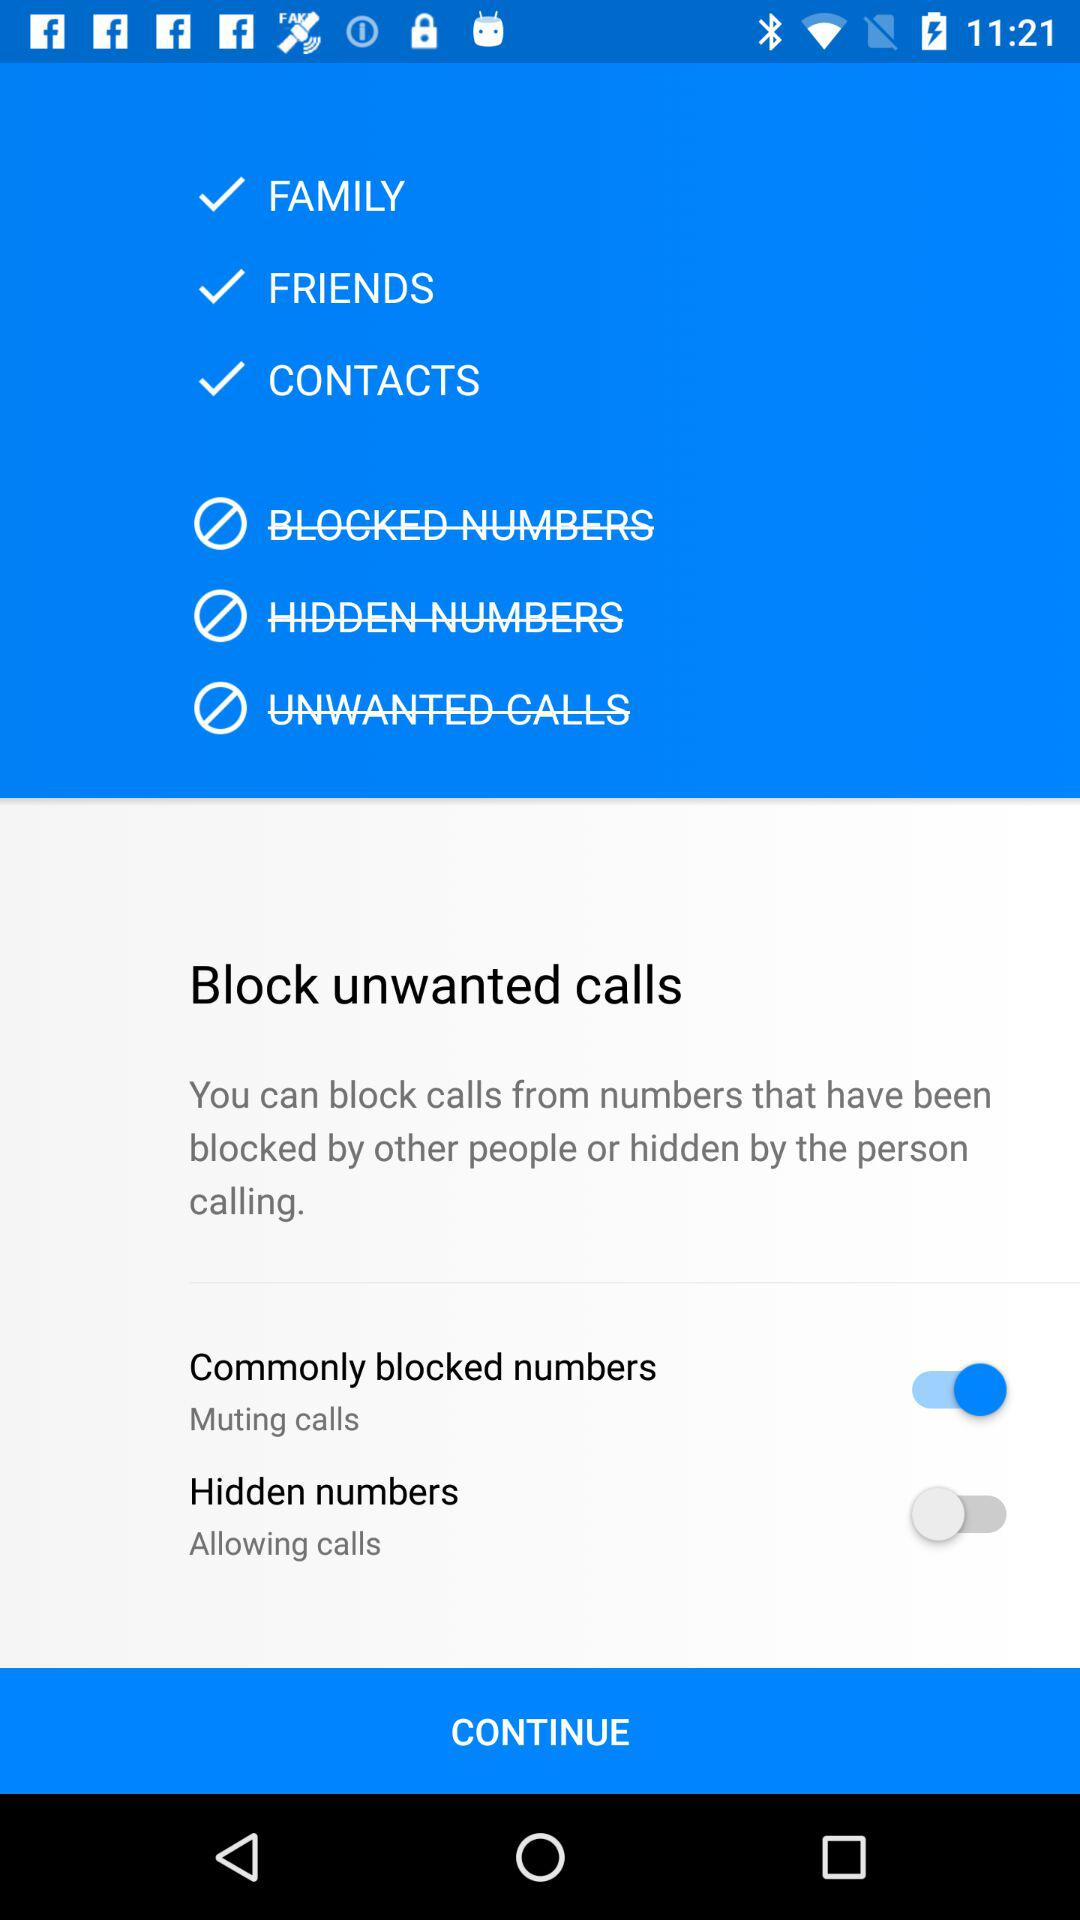Which option has been enabled? The option that has been enabled is "Commonly blocked numbers". 